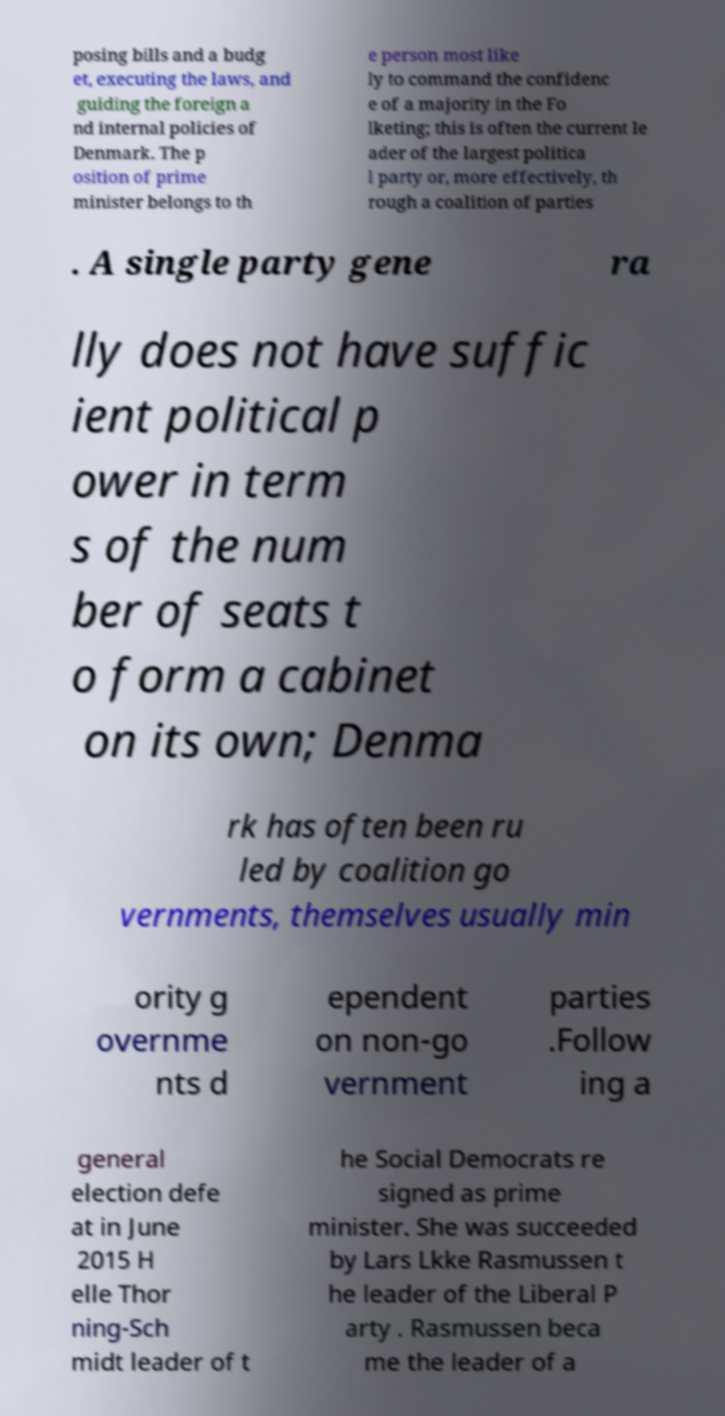Please read and relay the text visible in this image. What does it say? posing bills and a budg et, executing the laws, and guiding the foreign a nd internal policies of Denmark. The p osition of prime minister belongs to th e person most like ly to command the confidenc e of a majority in the Fo lketing; this is often the current le ader of the largest politica l party or, more effectively, th rough a coalition of parties . A single party gene ra lly does not have suffic ient political p ower in term s of the num ber of seats t o form a cabinet on its own; Denma rk has often been ru led by coalition go vernments, themselves usually min ority g overnme nts d ependent on non-go vernment parties .Follow ing a general election defe at in June 2015 H elle Thor ning-Sch midt leader of t he Social Democrats re signed as prime minister. She was succeeded by Lars Lkke Rasmussen t he leader of the Liberal P arty . Rasmussen beca me the leader of a 